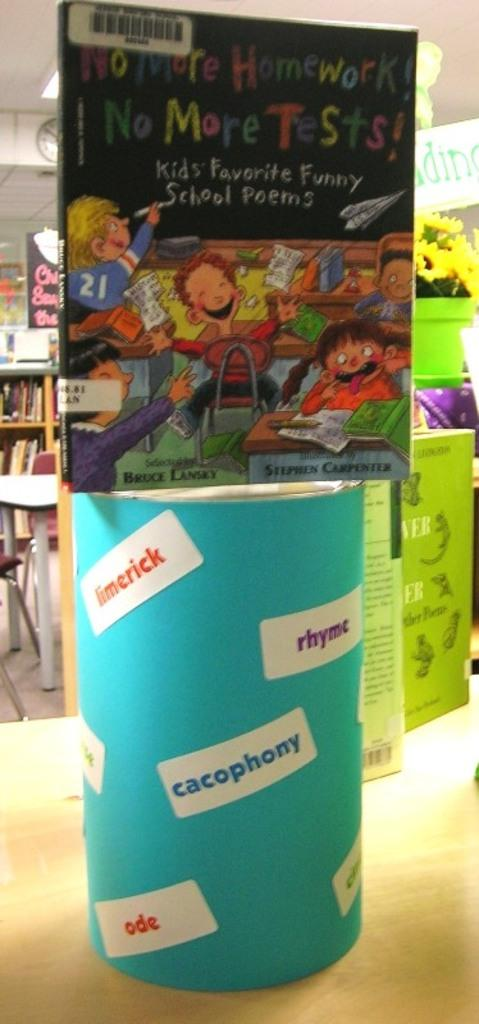<image>
Write a terse but informative summary of the picture. Giant book titled "No More Homework!" on top of a blue can. 